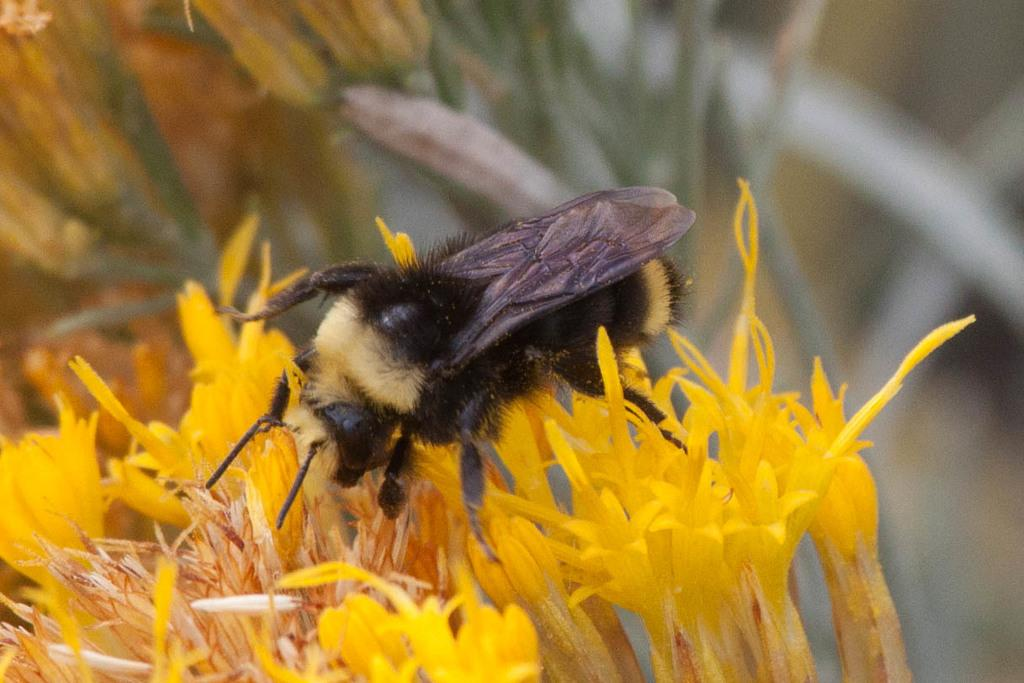What type of creature is in the image? There is an insect in the image. Can you describe the color of the insect? The insect is black and cream colored. Where is the insect located in the image? The insect is on a flower. What color is the flower? The flower is yellow. How would you describe the background of the image? The background of the image is blurred. What type of legal advice is the insect providing in the image? There is no indication in the image that the insect is providing legal advice, as insects do not have the ability to practice law. 